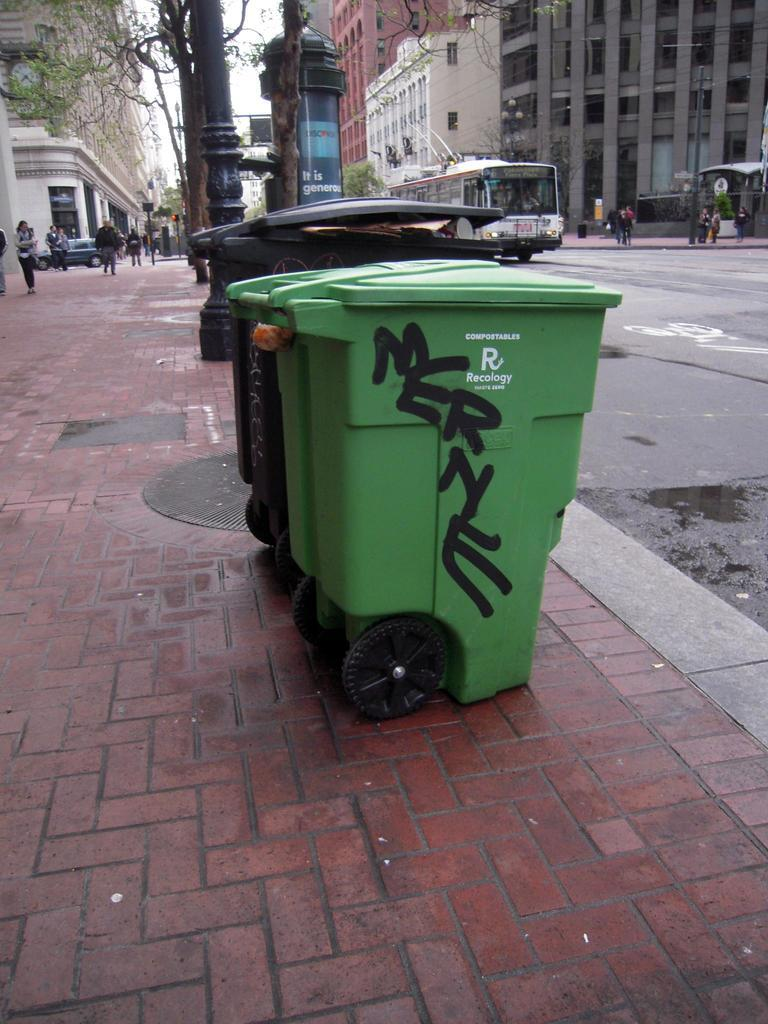<image>
Describe the image concisely. Two large trash cans, one balck the other green taht has the word MERNE spraypainted on it. 